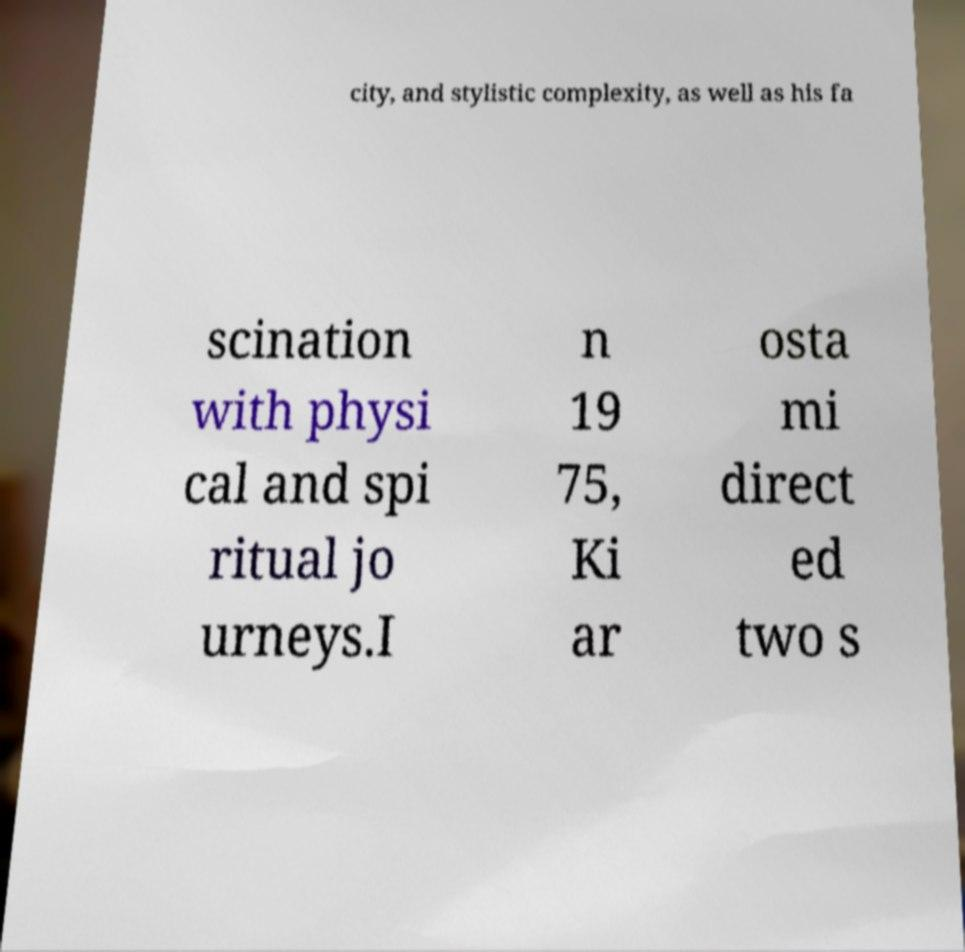Can you read and provide the text displayed in the image?This photo seems to have some interesting text. Can you extract and type it out for me? city, and stylistic complexity, as well as his fa scination with physi cal and spi ritual jo urneys.I n 19 75, Ki ar osta mi direct ed two s 